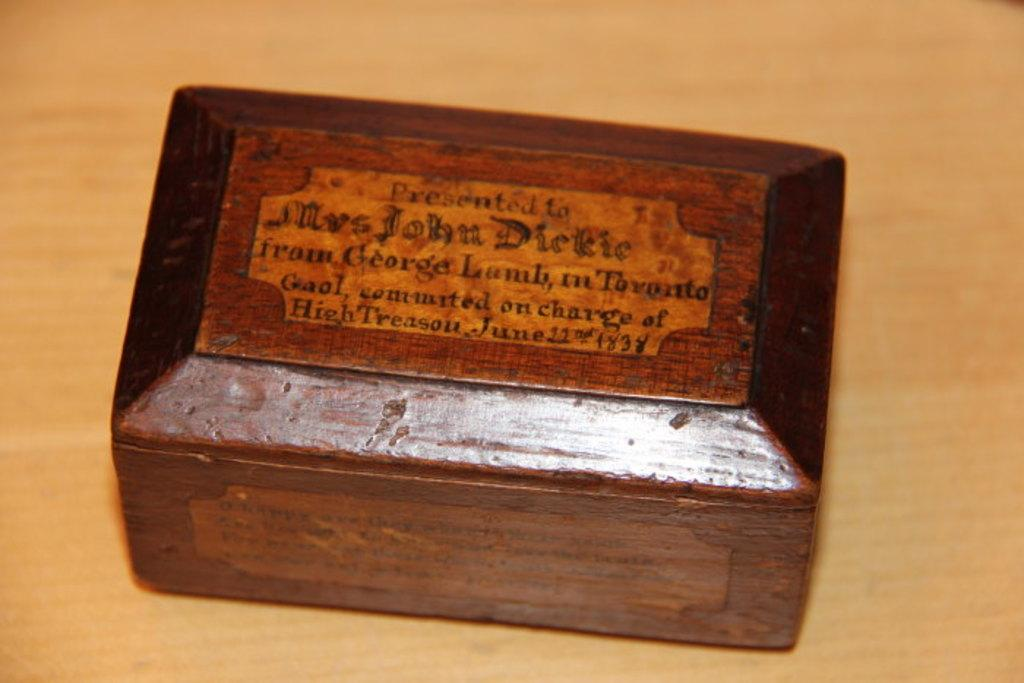<image>
Give a short and clear explanation of the subsequent image. A wooden box bears the name Mrs. John Dickie. 